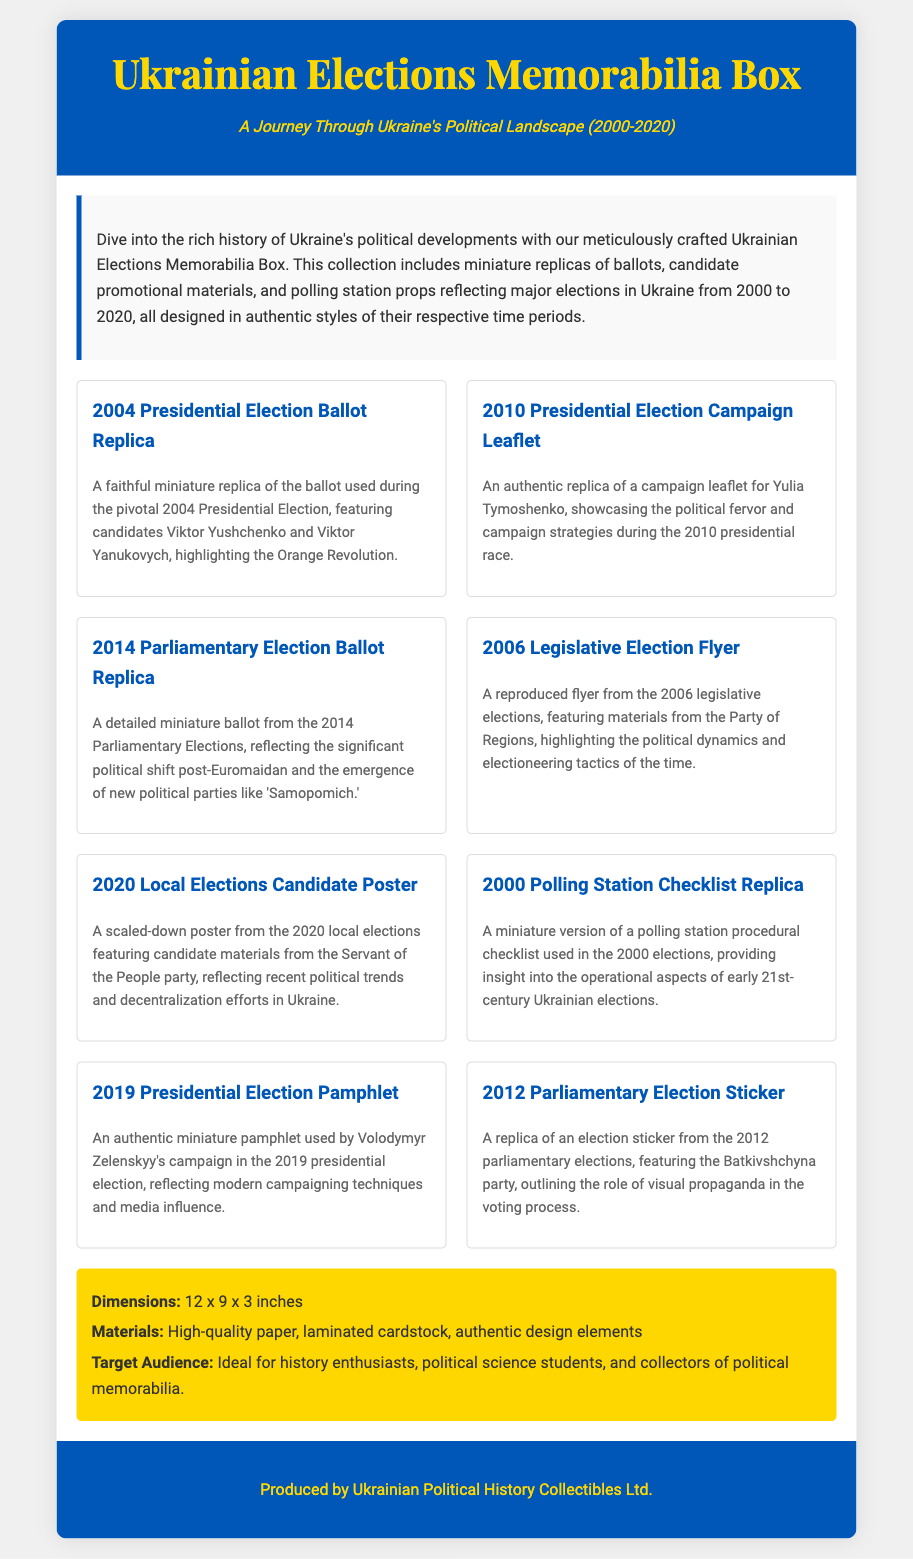what is included in the memorabilia box? The box includes miniature replicas of ballots, candidate promotional materials, and polling station props reflecting major elections in Ukraine.
Answer: miniature replicas of ballots, candidate promotional materials, and polling station props what year did the Orange Revolution take place? The description of the 2004 Presidential Election Ballot Replica mentions that the Orange Revolution is associated with that election.
Answer: 2004 which political party's materials are featured in the 2020 local elections item? The description for the 2020 Local Elections Candidate Poster states it features candidate materials from the Servant of the People party.
Answer: Servant of the People how many different election items are showcased in the box? The content of the document lists a total of eight different election items included in the memorabilia box.
Answer: eight what type of replica is associated with the 2000 elections? The document mentions a polling station procedural checklist replica for the year 2000.
Answer: polling station checklist what material is used for the items in the memorabilia box? The information section states that high-quality paper and laminated cardstock are the materials used for the items.
Answer: high-quality paper, laminated cardstock who produced the Ukrainian Elections Memorabilia Box? The footer of the document states that it was produced by Ukrainian Political History Collectibles Ltd.
Answer: Ukrainian Political History Collectibles Ltd what significant political event is reflected in the 2014 Parliamentary Election item? The description for the 2014 Parliamentary Election Ballot Replica notes a significant political shift post-Euromaidan.
Answer: post-Euromaidan 